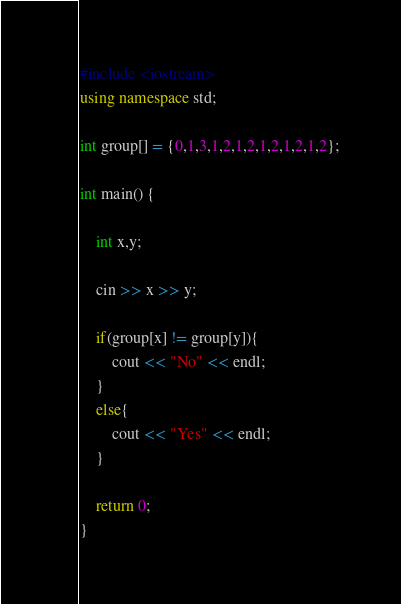<code> <loc_0><loc_0><loc_500><loc_500><_C++_>#include <iostream>
using namespace std;

int group[] = {0,1,3,1,2,1,2,1,2,1,2,1,2};

int main() {

    int x,y;

    cin >> x >> y;

    if(group[x] != group[y]){
        cout << "No" << endl;
    }
    else{
        cout << "Yes" << endl;
    }

    return 0;
}</code> 